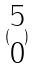Convert formula to latex. <formula><loc_0><loc_0><loc_500><loc_500>( \begin{matrix} 5 \\ 0 \end{matrix} )</formula> 